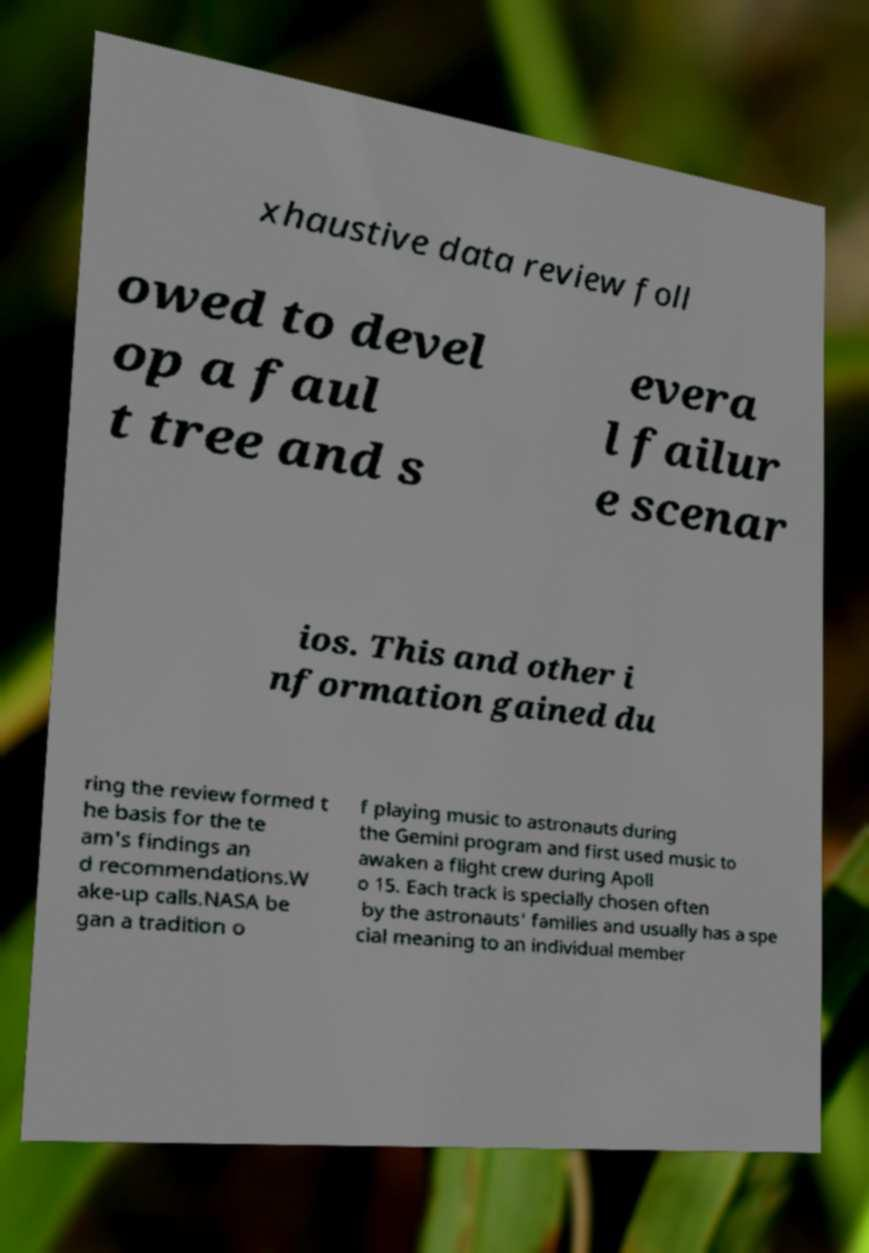For documentation purposes, I need the text within this image transcribed. Could you provide that? xhaustive data review foll owed to devel op a faul t tree and s evera l failur e scenar ios. This and other i nformation gained du ring the review formed t he basis for the te am's findings an d recommendations.W ake-up calls.NASA be gan a tradition o f playing music to astronauts during the Gemini program and first used music to awaken a flight crew during Apoll o 15. Each track is specially chosen often by the astronauts' families and usually has a spe cial meaning to an individual member 